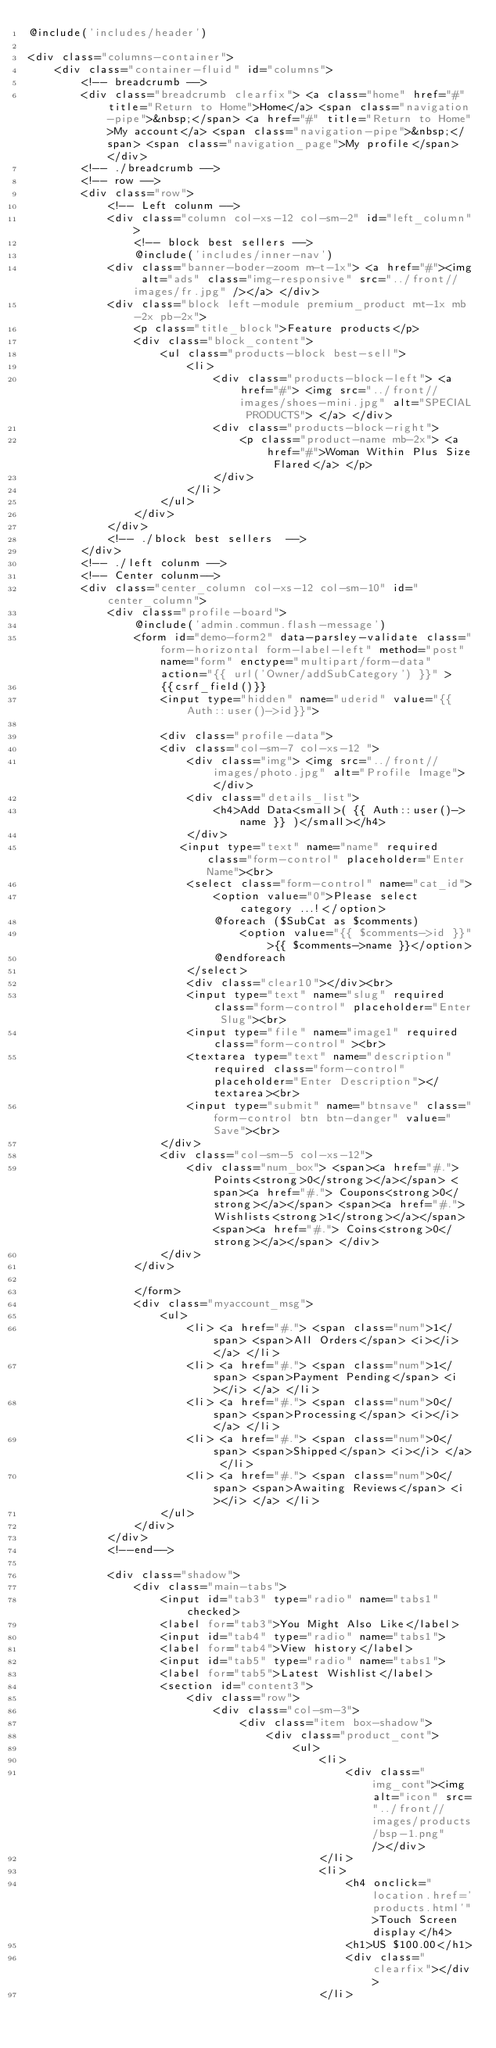Convert code to text. <code><loc_0><loc_0><loc_500><loc_500><_PHP_>@include('includes/header')

<div class="columns-container">
    <div class="container-fluid" id="columns">
        <!-- breadcrumb -->
        <div class="breadcrumb clearfix"> <a class="home" href="#" title="Return to Home">Home</a> <span class="navigation-pipe">&nbsp;</span> <a href="#" title="Return to Home">My account</a> <span class="navigation-pipe">&nbsp;</span> <span class="navigation_page">My profile</span> </div>
        <!-- ./breadcrumb -->
        <!-- row -->
        <div class="row">
            <!-- Left colunm -->
            <div class="column col-xs-12 col-sm-2" id="left_column">
                <!-- block best sellers -->
                @include('includes/inner-nav')
            <div class="banner-boder-zoom m-t-1x"> <a href="#"><img alt="ads" class="img-responsive" src="../front//images/fr.jpg" /></a> </div>
            <div class="block left-module premium_product mt-1x mb-2x pb-2x">
                <p class="title_block">Feature products</p>
                <div class="block_content">
                    <ul class="products-block best-sell">
                        <li>
                            <div class="products-block-left"> <a href="#"> <img src="../front//images/shoes-mini.jpg" alt="SPECIAL PRODUCTS"> </a> </div>
                            <div class="products-block-right">
                                <p class="product-name mb-2x"> <a href="#">Woman Within Plus Size Flared</a> </p>
                            </div>
                        </li>
                    </ul>
                </div>
            </div>
            <!-- ./block best sellers  -->
        </div>
        <!-- ./left colunm -->
        <!-- Center colunm-->
        <div class="center_column col-xs-12 col-sm-10" id="center_column">
            <div class="profile-board">
                @include('admin.commun.flash-message')
                <form id="demo-form2" data-parsley-validate class="form-horizontal form-label-left" method="post" name="form" enctype="multipart/form-data" action="{{ url('Owner/addSubCategory') }}" >
                    {{csrf_field()}}
                    <input type="hidden" name="uderid" value="{{ Auth::user()->id}}">

                    <div class="profile-data">
                    <div class="col-sm-7 col-xs-12 ">
                        <div class="img"> <img src="../front//images/photo.jpg" alt="Profile Image"> </div>
                        <div class="details_list">
                            <h4>Add Data<small>( {{ Auth::user()->name }} )</small></h4>
                        </div>
                       <input type="text" name="name" required class="form-control" placeholder="Enter Name"><br>
                        <select class="form-control" name="cat_id">
                            <option value="0">Please select category ...!</option>
                            @foreach ($SubCat as $comments)
                                <option value="{{ $comments->id }}">{{ $comments->name }}</option>
                            @endforeach
                        </select>
                        <div class="clear10"></div><br>
                        <input type="text" name="slug" required class="form-control" placeholder="Enter Slug"><br>
                        <input type="file" name="image1" required class="form-control" ><br>
                        <textarea type="text" name="description" required class="form-control" placeholder="Enter Description"></textarea><br>
                        <input type="submit" name="btnsave" class="form-control btn btn-danger" value="Save"><br>
                    </div>
                    <div class="col-sm-5 col-xs-12">
                        <div class="num_box"> <span><a href="#."> Points<strong>0</strong></a></span> <span><a href="#."> Coupons<strong>0</strong></a></span> <span><a href="#."> Wishlists<strong>1</strong></a></span> <span><a href="#."> Coins<strong>0</strong></a></span> </div>
                    </div>
                </div>

                </form>
                <div class="myaccount_msg">
                    <ul>
                        <li> <a href="#."> <span class="num">1</span> <span>All Orders</span> <i></i> </a> </li>
                        <li> <a href="#."> <span class="num">1</span> <span>Payment Pending</span> <i></i> </a> </li>
                        <li> <a href="#."> <span class="num">0</span> <span>Processing</span> <i></i> </a> </li>
                        <li> <a href="#."> <span class="num">0</span> <span>Shipped</span> <i></i> </a> </li>
                        <li> <a href="#."> <span class="num">0</span> <span>Awaiting Reviews</span> <i></i> </a> </li>
                    </ul>
                </div>
            </div>
            <!--end-->

            <div class="shadow">
                <div class="main-tabs">
                    <input id="tab3" type="radio" name="tabs1" checked>
                    <label for="tab3">You Might Also Like</label>
                    <input id="tab4" type="radio" name="tabs1">
                    <label for="tab4">View history</label>
                    <input id="tab5" type="radio" name="tabs1">
                    <label for="tab5">Latest Wishlist</label>
                    <section id="content3">
                        <div class="row">
                            <div class="col-sm-3">
                                <div class="item box-shadow">
                                    <div class="product_cont">
                                        <ul>
                                            <li>
                                                <div class="img_cont"><img alt="icon" src="../front//images/products/bsp-1.png" /></div>
                                            </li>
                                            <li>
                                                <h4 onclick="location.href='products.html'">Touch Screen display</h4>
                                                <h1>US $100.00</h1>
                                                <div class="clearfix"></div>
                                            </li></code> 